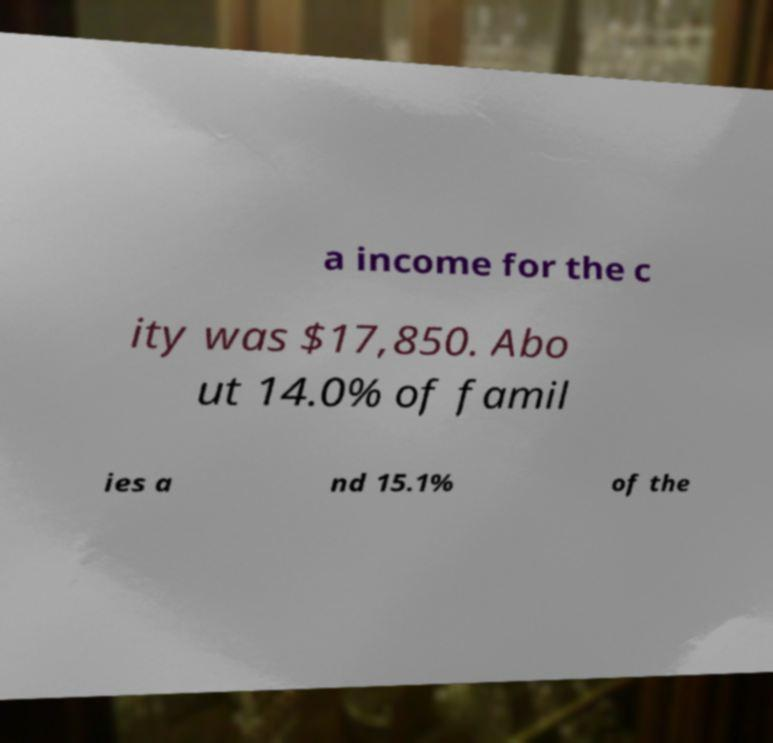Can you read and provide the text displayed in the image?This photo seems to have some interesting text. Can you extract and type it out for me? a income for the c ity was $17,850. Abo ut 14.0% of famil ies a nd 15.1% of the 